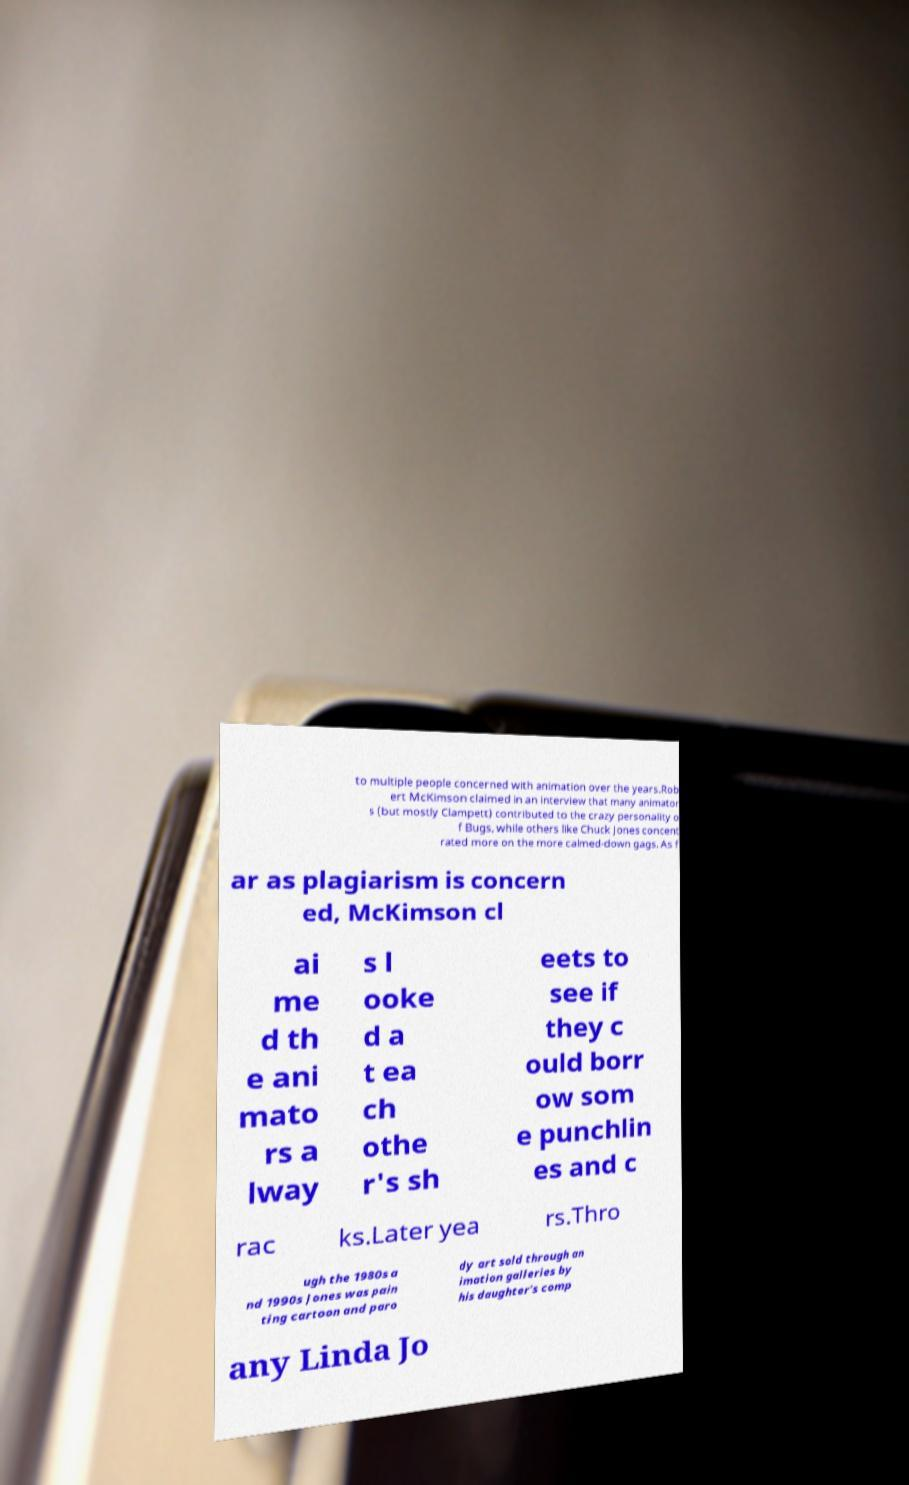Can you read and provide the text displayed in the image?This photo seems to have some interesting text. Can you extract and type it out for me? to multiple people concerned with animation over the years.Rob ert McKimson claimed in an interview that many animator s (but mostly Clampett) contributed to the crazy personality o f Bugs, while others like Chuck Jones concent rated more on the more calmed-down gags. As f ar as plagiarism is concern ed, McKimson cl ai me d th e ani mato rs a lway s l ooke d a t ea ch othe r's sh eets to see if they c ould borr ow som e punchlin es and c rac ks.Later yea rs.Thro ugh the 1980s a nd 1990s Jones was pain ting cartoon and paro dy art sold through an imation galleries by his daughter's comp any Linda Jo 